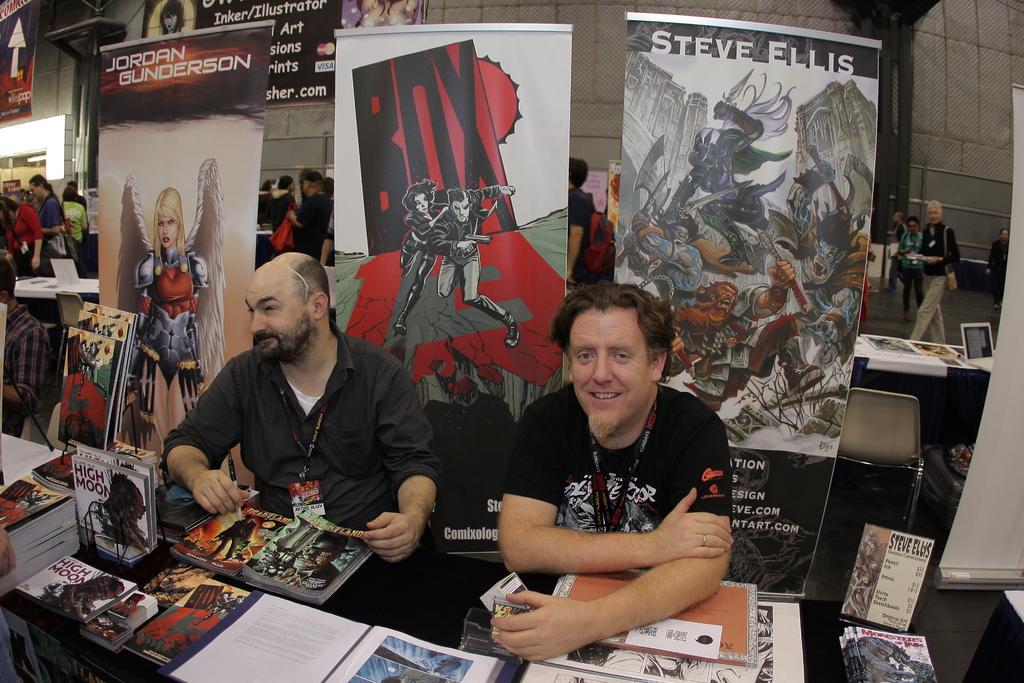Who is the author sitting on the right?
Your answer should be very brief. Steve ellis. What is the name of the white magazine?
Keep it short and to the point. Unanswerable. 